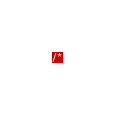<code> <loc_0><loc_0><loc_500><loc_500><_JavaScript_>/*</code> 